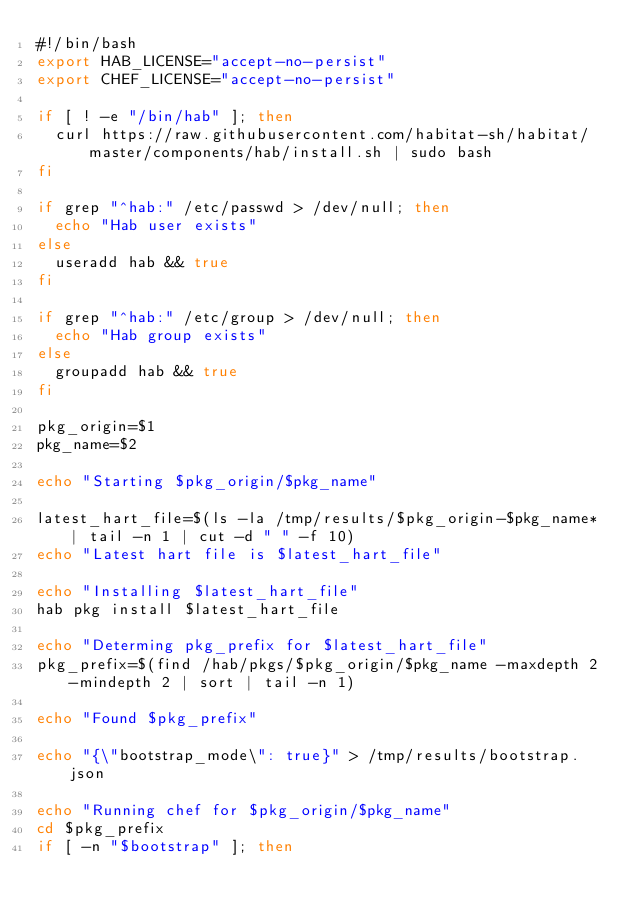<code> <loc_0><loc_0><loc_500><loc_500><_Bash_>#!/bin/bash
export HAB_LICENSE="accept-no-persist"
export CHEF_LICENSE="accept-no-persist"

if [ ! -e "/bin/hab" ]; then
  curl https://raw.githubusercontent.com/habitat-sh/habitat/master/components/hab/install.sh | sudo bash
fi

if grep "^hab:" /etc/passwd > /dev/null; then
  echo "Hab user exists"
else
  useradd hab && true
fi

if grep "^hab:" /etc/group > /dev/null; then
  echo "Hab group exists"
else
  groupadd hab && true
fi

pkg_origin=$1
pkg_name=$2

echo "Starting $pkg_origin/$pkg_name"

latest_hart_file=$(ls -la /tmp/results/$pkg_origin-$pkg_name* | tail -n 1 | cut -d " " -f 10)
echo "Latest hart file is $latest_hart_file"

echo "Installing $latest_hart_file"
hab pkg install $latest_hart_file

echo "Determing pkg_prefix for $latest_hart_file"
pkg_prefix=$(find /hab/pkgs/$pkg_origin/$pkg_name -maxdepth 2 -mindepth 2 | sort | tail -n 1)

echo "Found $pkg_prefix"

echo "{\"bootstrap_mode\": true}" > /tmp/results/bootstrap.json

echo "Running chef for $pkg_origin/$pkg_name"
cd $pkg_prefix
if [ -n "$bootstrap" ]; then</code> 